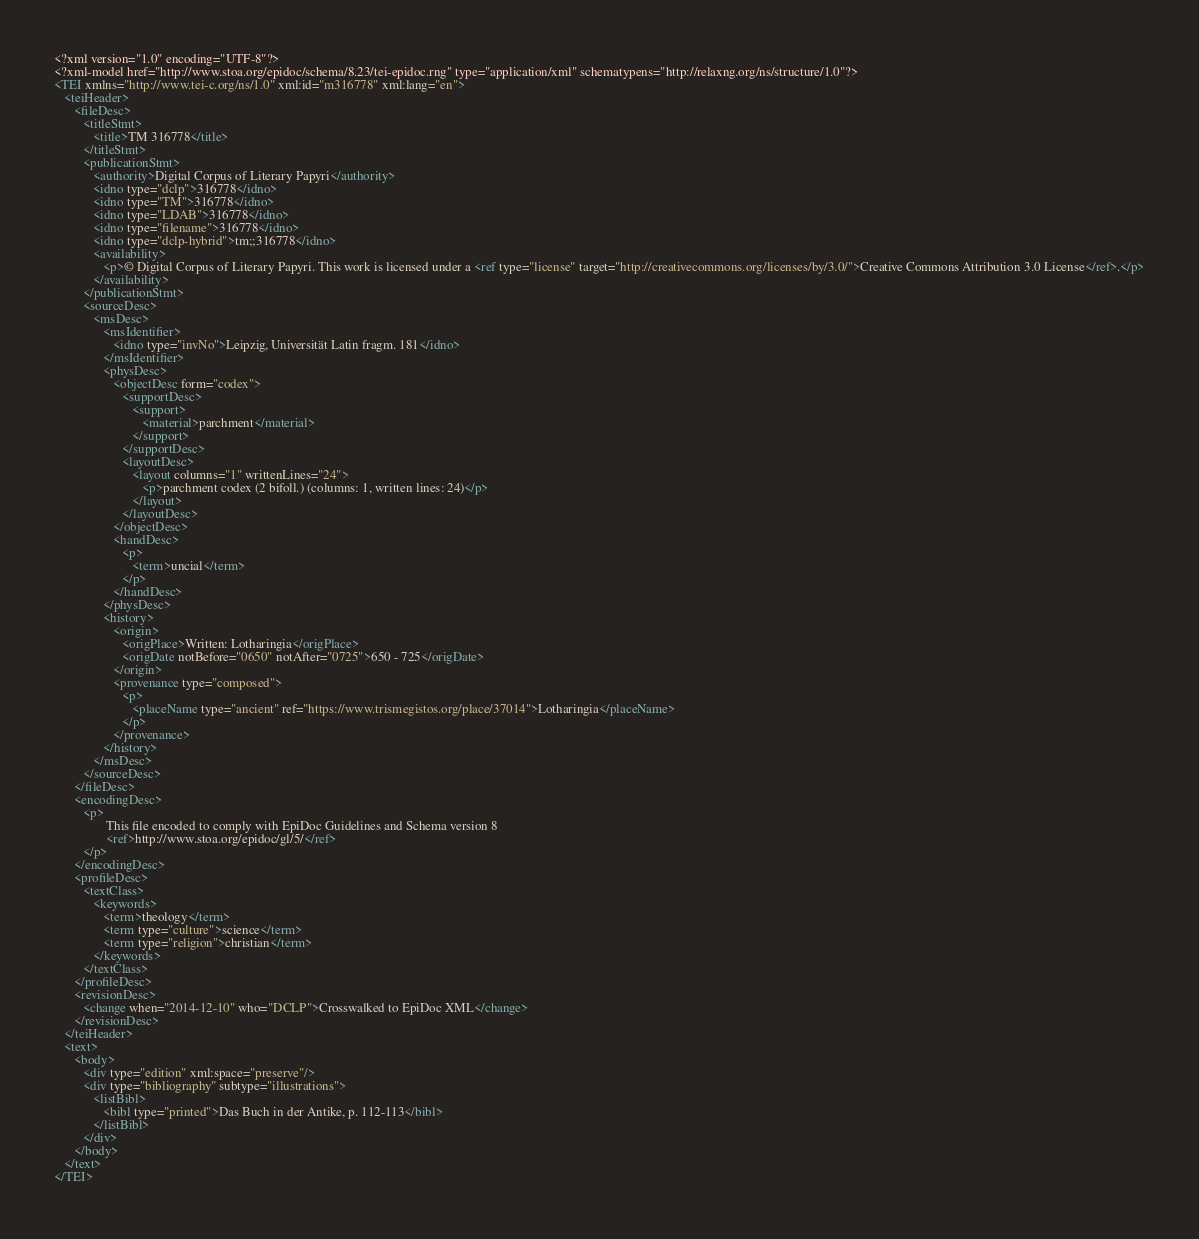<code> <loc_0><loc_0><loc_500><loc_500><_XML_><?xml version="1.0" encoding="UTF-8"?>
<?xml-model href="http://www.stoa.org/epidoc/schema/8.23/tei-epidoc.rng" type="application/xml" schematypens="http://relaxng.org/ns/structure/1.0"?>
<TEI xmlns="http://www.tei-c.org/ns/1.0" xml:id="m316778" xml:lang="en">
   <teiHeader>
      <fileDesc>
         <titleStmt>
            <title>TM 316778</title>
         </titleStmt>
         <publicationStmt>
            <authority>Digital Corpus of Literary Papyri</authority>
            <idno type="dclp">316778</idno>
            <idno type="TM">316778</idno>
            <idno type="LDAB">316778</idno>
            <idno type="filename">316778</idno>
            <idno type="dclp-hybrid">tm;;316778</idno>
            <availability>
               <p>© Digital Corpus of Literary Papyri. This work is licensed under a <ref type="license" target="http://creativecommons.org/licenses/by/3.0/">Creative Commons Attribution 3.0 License</ref>.</p>
            </availability>
         </publicationStmt>
         <sourceDesc>
            <msDesc>
               <msIdentifier>
                  <idno type="invNo">Leipzig, Universität Latin fragm. 181</idno>
               </msIdentifier>
               <physDesc>
                  <objectDesc form="codex">
                     <supportDesc>
                        <support>
                           <material>parchment</material>
                        </support>
                     </supportDesc>
                     <layoutDesc>
                        <layout columns="1" writtenLines="24">
                           <p>parchment codex (2 bifoll.) (columns: 1, written lines: 24)</p>
                        </layout>
                     </layoutDesc>
                  </objectDesc>
                  <handDesc>
                     <p>
                        <term>uncial</term>
                     </p>
                  </handDesc>
               </physDesc>
               <history>
                  <origin>
                     <origPlace>Written: Lotharingia</origPlace>
                     <origDate notBefore="0650" notAfter="0725">650 - 725</origDate>
                  </origin>
                  <provenance type="composed">
                     <p>
                        <placeName type="ancient" ref="https://www.trismegistos.org/place/37014">Lotharingia</placeName>
                     </p>
                  </provenance>
               </history>
            </msDesc>
         </sourceDesc>
      </fileDesc>
      <encodingDesc>
         <p>
                This file encoded to comply with EpiDoc Guidelines and Schema version 8
                <ref>http://www.stoa.org/epidoc/gl/5/</ref>
         </p>
      </encodingDesc>
      <profileDesc>
         <textClass>
            <keywords>
               <term>theology</term>
               <term type="culture">science</term>
               <term type="religion">christian</term>
            </keywords>
         </textClass>
      </profileDesc>
      <revisionDesc>
         <change when="2014-12-10" who="DCLP">Crosswalked to EpiDoc XML</change>
      </revisionDesc>
   </teiHeader>
   <text>
      <body>
         <div type="edition" xml:space="preserve"/>
         <div type="bibliography" subtype="illustrations">
            <listBibl>
               <bibl type="printed">Das Buch in der Antike, p. 112-113</bibl>
            </listBibl>
         </div>
      </body>
   </text>
</TEI>
</code> 